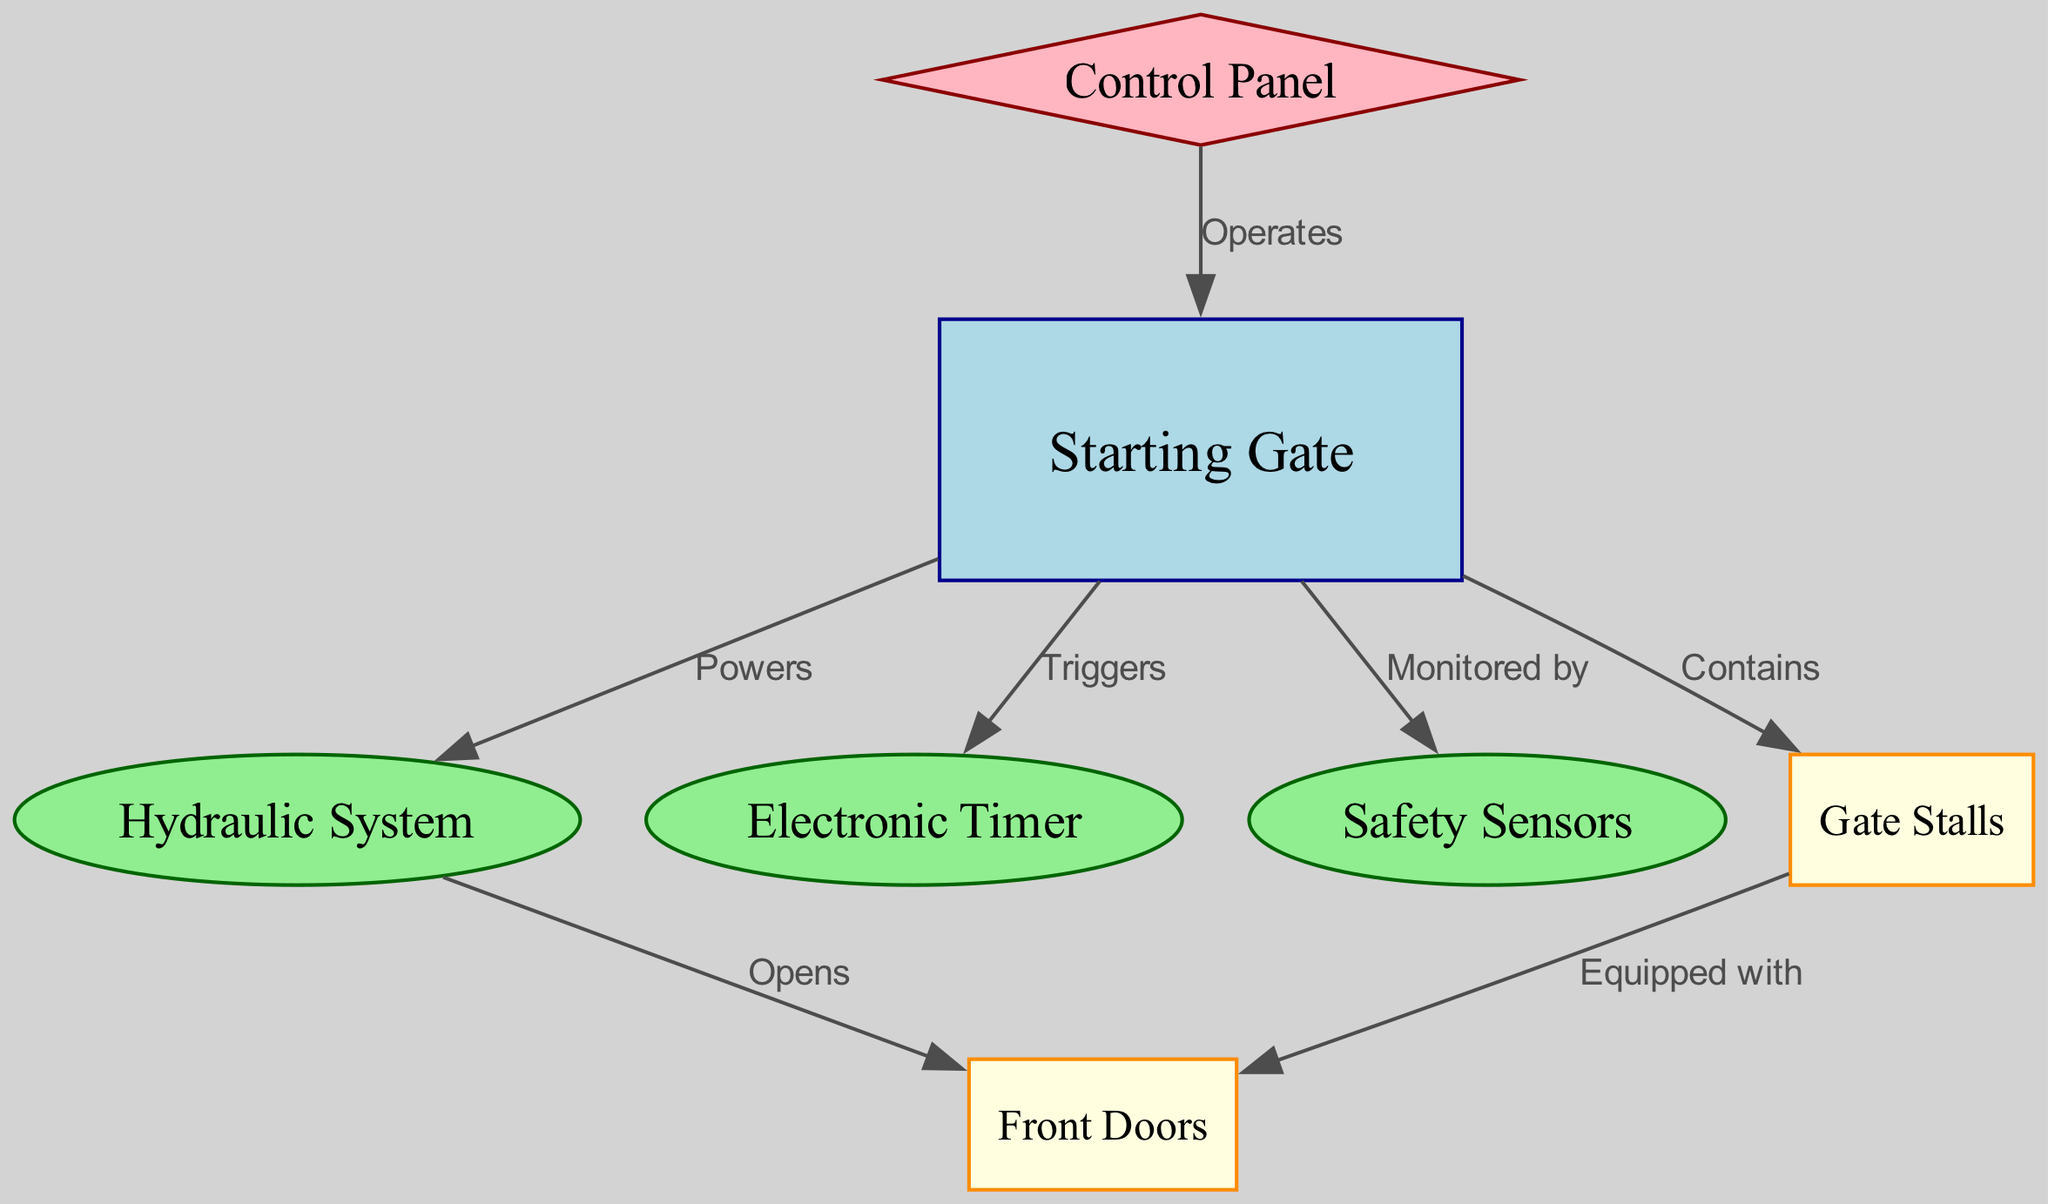What is the main structure represented in the diagram? The diagram primarily shows the "Starting Gate" as the main structure, which is a rectangular node, distinctly colored.
Answer: Starting Gate How many main components (nodes) does the diagram include? The diagram has three main components, represented as ellipses: Hydraulic System, Electronic Timer, and Safety Sensors.
Answer: 3 Which node is equipped with the "Front Doors"? The "Gate Stalls" node has an edge labeled "Equipped with" that points to the "Front Doors" node.
Answer: Gate Stalls What system powers the starting gate? The edge labeled "Powers" connects the "Starting Gate" to the "Hydraulic System," indicating that the hydraulic system provides power to the gate.
Answer: Hydraulic System Which node operates the starting gate? The "Control Panel" node is connected to the "Starting Gate" with an edge labeled "Operates," indicating it is responsible for the operation of the gate.
Answer: Control Panel What is the relationship between the starting gate and the electronic timer? The edge labeled "Triggers" indicates that the "Starting Gate" triggers the "Electronic Timer," showing a direct functional connection.
Answer: Triggers What monitors the starting gate's safety features? The edge labeled "Monitored by" connects the "Safety Sensors" to the "Starting Gate," demonstrating that safety sensors are responsible for monitoring safety features.
Answer: Safety Sensors Which components interact with the front doors of the starting gate? The "Hydraulic System" opens the "Front Doors," while these doors are equipped with the "Gate Stalls," showing interaction through edges.
Answer: Hydraulic System and Gate Stalls What role does the hydraulic system have in the mechanism? The "Hydraulic System" is shown to open the "Front Doors," indicating its active role in controlling the gate's opening mechanism.
Answer: Opens What part contains the gate stalls? The "Starting Gate" node is linked to the "Gate Stalls" node with the edge labeled "Contains," which indicates that the starting gate houses the stalls.
Answer: Starting Gate 